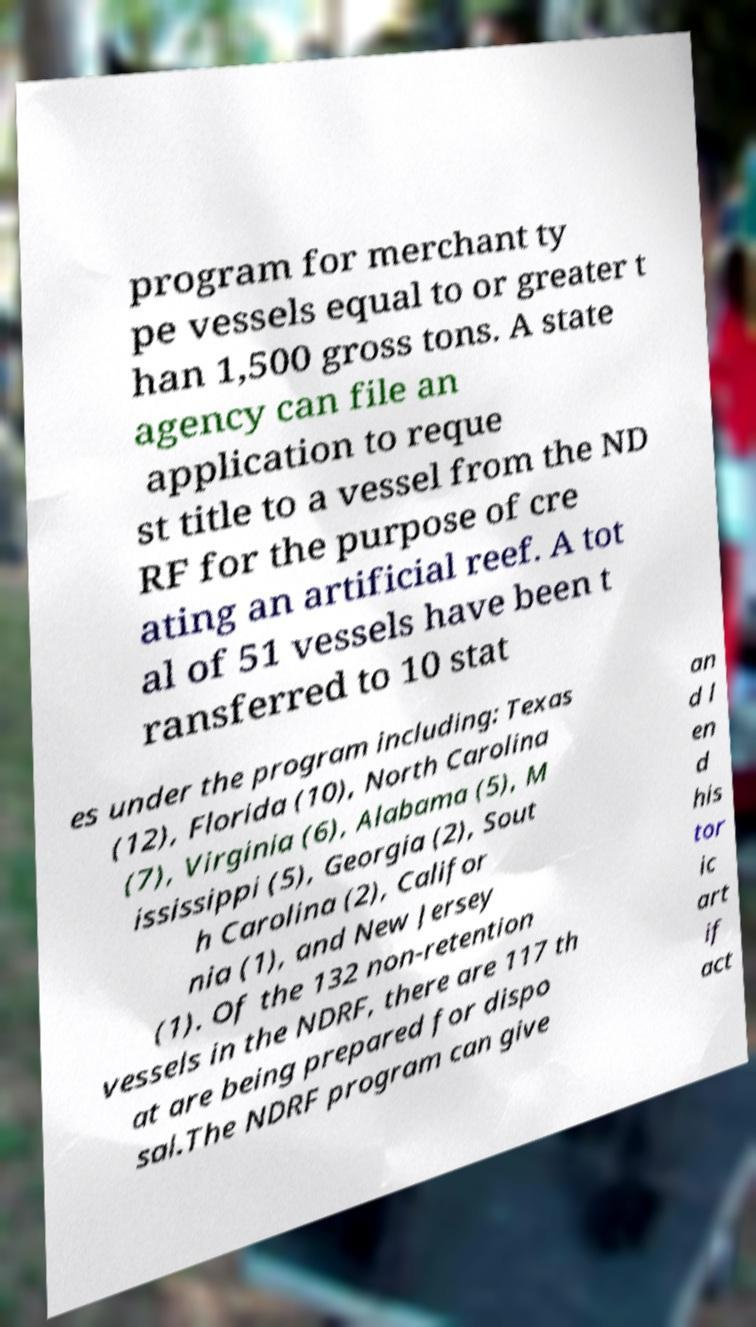There's text embedded in this image that I need extracted. Can you transcribe it verbatim? program for merchant ty pe vessels equal to or greater t han 1,500 gross tons. A state agency can file an application to reque st title to a vessel from the ND RF for the purpose of cre ating an artificial reef. A tot al of 51 vessels have been t ransferred to 10 stat es under the program including: Texas (12), Florida (10), North Carolina (7), Virginia (6), Alabama (5), M ississippi (5), Georgia (2), Sout h Carolina (2), Califor nia (1), and New Jersey (1). Of the 132 non-retention vessels in the NDRF, there are 117 th at are being prepared for dispo sal.The NDRF program can give an d l en d his tor ic art if act 